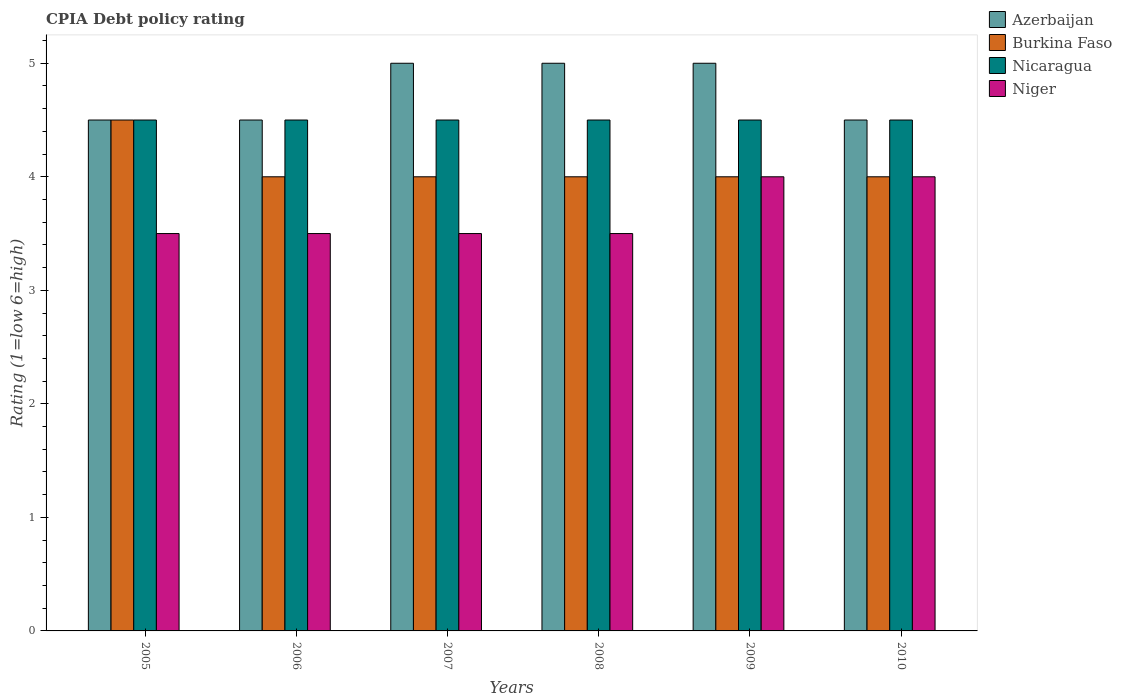How many different coloured bars are there?
Your answer should be very brief. 4. Are the number of bars per tick equal to the number of legend labels?
Your answer should be very brief. Yes. Are the number of bars on each tick of the X-axis equal?
Make the answer very short. Yes. How many bars are there on the 6th tick from the right?
Your answer should be very brief. 4. What is the label of the 6th group of bars from the left?
Your response must be concise. 2010. Across all years, what is the maximum CPIA rating in Niger?
Your answer should be very brief. 4. In which year was the CPIA rating in Niger minimum?
Make the answer very short. 2005. What is the total CPIA rating in Niger in the graph?
Offer a terse response. 22. What is the difference between the CPIA rating in Nicaragua in 2005 and that in 2009?
Offer a terse response. 0. What is the average CPIA rating in Azerbaijan per year?
Offer a terse response. 4.75. In the year 2005, what is the difference between the CPIA rating in Niger and CPIA rating in Azerbaijan?
Provide a succinct answer. -1. In how many years, is the CPIA rating in Azerbaijan greater than 3.4?
Your answer should be compact. 6. Is the CPIA rating in Niger in 2007 less than that in 2010?
Provide a succinct answer. Yes. Is the difference between the CPIA rating in Niger in 2006 and 2009 greater than the difference between the CPIA rating in Azerbaijan in 2006 and 2009?
Give a very brief answer. No. What does the 3rd bar from the left in 2008 represents?
Ensure brevity in your answer.  Nicaragua. What does the 1st bar from the right in 2006 represents?
Make the answer very short. Niger. Is it the case that in every year, the sum of the CPIA rating in Azerbaijan and CPIA rating in Niger is greater than the CPIA rating in Burkina Faso?
Your answer should be compact. Yes. Are the values on the major ticks of Y-axis written in scientific E-notation?
Your answer should be compact. No. Does the graph contain any zero values?
Your answer should be very brief. No. Where does the legend appear in the graph?
Your answer should be very brief. Top right. How many legend labels are there?
Ensure brevity in your answer.  4. What is the title of the graph?
Provide a succinct answer. CPIA Debt policy rating. Does "Sudan" appear as one of the legend labels in the graph?
Your answer should be very brief. No. What is the Rating (1=low 6=high) of Azerbaijan in 2005?
Provide a succinct answer. 4.5. What is the Rating (1=low 6=high) in Burkina Faso in 2005?
Your answer should be compact. 4.5. What is the Rating (1=low 6=high) in Nicaragua in 2005?
Your response must be concise. 4.5. What is the Rating (1=low 6=high) in Nicaragua in 2006?
Make the answer very short. 4.5. What is the Rating (1=low 6=high) in Niger in 2006?
Provide a succinct answer. 3.5. What is the Rating (1=low 6=high) in Burkina Faso in 2007?
Your answer should be compact. 4. What is the Rating (1=low 6=high) of Nicaragua in 2007?
Your answer should be compact. 4.5. What is the Rating (1=low 6=high) of Niger in 2007?
Your response must be concise. 3.5. What is the Rating (1=low 6=high) of Azerbaijan in 2008?
Your answer should be very brief. 5. What is the Rating (1=low 6=high) in Nicaragua in 2008?
Offer a terse response. 4.5. What is the Rating (1=low 6=high) in Azerbaijan in 2009?
Provide a short and direct response. 5. What is the Rating (1=low 6=high) in Nicaragua in 2009?
Offer a terse response. 4.5. What is the Rating (1=low 6=high) in Niger in 2009?
Your response must be concise. 4. What is the Rating (1=low 6=high) of Burkina Faso in 2010?
Provide a succinct answer. 4. What is the Rating (1=low 6=high) of Niger in 2010?
Your answer should be very brief. 4. Across all years, what is the maximum Rating (1=low 6=high) in Burkina Faso?
Offer a very short reply. 4.5. Across all years, what is the maximum Rating (1=low 6=high) of Niger?
Offer a terse response. 4. Across all years, what is the minimum Rating (1=low 6=high) in Burkina Faso?
Provide a short and direct response. 4. What is the total Rating (1=low 6=high) in Burkina Faso in the graph?
Ensure brevity in your answer.  24.5. What is the total Rating (1=low 6=high) in Niger in the graph?
Your answer should be compact. 22. What is the difference between the Rating (1=low 6=high) in Azerbaijan in 2005 and that in 2006?
Your answer should be compact. 0. What is the difference between the Rating (1=low 6=high) of Nicaragua in 2005 and that in 2006?
Your response must be concise. 0. What is the difference between the Rating (1=low 6=high) of Niger in 2005 and that in 2006?
Ensure brevity in your answer.  0. What is the difference between the Rating (1=low 6=high) in Burkina Faso in 2005 and that in 2007?
Keep it short and to the point. 0.5. What is the difference between the Rating (1=low 6=high) of Nicaragua in 2005 and that in 2007?
Ensure brevity in your answer.  0. What is the difference between the Rating (1=low 6=high) of Azerbaijan in 2005 and that in 2008?
Make the answer very short. -0.5. What is the difference between the Rating (1=low 6=high) in Nicaragua in 2005 and that in 2008?
Make the answer very short. 0. What is the difference between the Rating (1=low 6=high) of Azerbaijan in 2005 and that in 2009?
Keep it short and to the point. -0.5. What is the difference between the Rating (1=low 6=high) of Niger in 2005 and that in 2009?
Provide a succinct answer. -0.5. What is the difference between the Rating (1=low 6=high) of Nicaragua in 2005 and that in 2010?
Your response must be concise. 0. What is the difference between the Rating (1=low 6=high) in Niger in 2005 and that in 2010?
Your response must be concise. -0.5. What is the difference between the Rating (1=low 6=high) of Azerbaijan in 2006 and that in 2007?
Offer a terse response. -0.5. What is the difference between the Rating (1=low 6=high) in Burkina Faso in 2006 and that in 2007?
Ensure brevity in your answer.  0. What is the difference between the Rating (1=low 6=high) of Nicaragua in 2006 and that in 2007?
Provide a succinct answer. 0. What is the difference between the Rating (1=low 6=high) in Niger in 2006 and that in 2007?
Provide a succinct answer. 0. What is the difference between the Rating (1=low 6=high) in Azerbaijan in 2006 and that in 2009?
Provide a succinct answer. -0.5. What is the difference between the Rating (1=low 6=high) of Niger in 2006 and that in 2009?
Keep it short and to the point. -0.5. What is the difference between the Rating (1=low 6=high) of Azerbaijan in 2006 and that in 2010?
Provide a succinct answer. 0. What is the difference between the Rating (1=low 6=high) in Burkina Faso in 2006 and that in 2010?
Your answer should be very brief. 0. What is the difference between the Rating (1=low 6=high) of Niger in 2006 and that in 2010?
Give a very brief answer. -0.5. What is the difference between the Rating (1=low 6=high) in Azerbaijan in 2007 and that in 2008?
Provide a short and direct response. 0. What is the difference between the Rating (1=low 6=high) of Burkina Faso in 2007 and that in 2008?
Your answer should be very brief. 0. What is the difference between the Rating (1=low 6=high) of Azerbaijan in 2007 and that in 2009?
Keep it short and to the point. 0. What is the difference between the Rating (1=low 6=high) of Nicaragua in 2007 and that in 2009?
Keep it short and to the point. 0. What is the difference between the Rating (1=low 6=high) of Azerbaijan in 2007 and that in 2010?
Provide a short and direct response. 0.5. What is the difference between the Rating (1=low 6=high) of Burkina Faso in 2008 and that in 2010?
Offer a very short reply. 0. What is the difference between the Rating (1=low 6=high) in Burkina Faso in 2009 and that in 2010?
Your answer should be compact. 0. What is the difference between the Rating (1=low 6=high) in Azerbaijan in 2005 and the Rating (1=low 6=high) in Nicaragua in 2006?
Your answer should be very brief. 0. What is the difference between the Rating (1=low 6=high) of Nicaragua in 2005 and the Rating (1=low 6=high) of Niger in 2006?
Your response must be concise. 1. What is the difference between the Rating (1=low 6=high) in Azerbaijan in 2005 and the Rating (1=low 6=high) in Burkina Faso in 2007?
Your answer should be very brief. 0.5. What is the difference between the Rating (1=low 6=high) in Azerbaijan in 2005 and the Rating (1=low 6=high) in Nicaragua in 2007?
Offer a very short reply. 0. What is the difference between the Rating (1=low 6=high) in Azerbaijan in 2005 and the Rating (1=low 6=high) in Niger in 2007?
Your response must be concise. 1. What is the difference between the Rating (1=low 6=high) of Burkina Faso in 2005 and the Rating (1=low 6=high) of Nicaragua in 2007?
Offer a terse response. 0. What is the difference between the Rating (1=low 6=high) of Azerbaijan in 2005 and the Rating (1=low 6=high) of Burkina Faso in 2008?
Your answer should be very brief. 0.5. What is the difference between the Rating (1=low 6=high) in Azerbaijan in 2005 and the Rating (1=low 6=high) in Nicaragua in 2008?
Make the answer very short. 0. What is the difference between the Rating (1=low 6=high) of Azerbaijan in 2005 and the Rating (1=low 6=high) of Niger in 2008?
Ensure brevity in your answer.  1. What is the difference between the Rating (1=low 6=high) of Burkina Faso in 2005 and the Rating (1=low 6=high) of Nicaragua in 2008?
Provide a succinct answer. 0. What is the difference between the Rating (1=low 6=high) of Azerbaijan in 2005 and the Rating (1=low 6=high) of Burkina Faso in 2009?
Keep it short and to the point. 0.5. What is the difference between the Rating (1=low 6=high) of Azerbaijan in 2005 and the Rating (1=low 6=high) of Nicaragua in 2009?
Ensure brevity in your answer.  0. What is the difference between the Rating (1=low 6=high) in Azerbaijan in 2005 and the Rating (1=low 6=high) in Niger in 2009?
Offer a terse response. 0.5. What is the difference between the Rating (1=low 6=high) of Burkina Faso in 2005 and the Rating (1=low 6=high) of Niger in 2009?
Give a very brief answer. 0.5. What is the difference between the Rating (1=low 6=high) in Nicaragua in 2005 and the Rating (1=low 6=high) in Niger in 2009?
Offer a very short reply. 0.5. What is the difference between the Rating (1=low 6=high) of Azerbaijan in 2006 and the Rating (1=low 6=high) of Nicaragua in 2007?
Offer a very short reply. 0. What is the difference between the Rating (1=low 6=high) of Burkina Faso in 2006 and the Rating (1=low 6=high) of Niger in 2007?
Offer a terse response. 0.5. What is the difference between the Rating (1=low 6=high) in Nicaragua in 2006 and the Rating (1=low 6=high) in Niger in 2007?
Your answer should be compact. 1. What is the difference between the Rating (1=low 6=high) in Azerbaijan in 2006 and the Rating (1=low 6=high) in Nicaragua in 2008?
Keep it short and to the point. 0. What is the difference between the Rating (1=low 6=high) of Azerbaijan in 2006 and the Rating (1=low 6=high) of Niger in 2008?
Provide a succinct answer. 1. What is the difference between the Rating (1=low 6=high) in Burkina Faso in 2006 and the Rating (1=low 6=high) in Niger in 2008?
Your answer should be very brief. 0.5. What is the difference between the Rating (1=low 6=high) in Burkina Faso in 2006 and the Rating (1=low 6=high) in Nicaragua in 2009?
Keep it short and to the point. -0.5. What is the difference between the Rating (1=low 6=high) of Burkina Faso in 2006 and the Rating (1=low 6=high) of Niger in 2009?
Provide a short and direct response. 0. What is the difference between the Rating (1=low 6=high) in Nicaragua in 2006 and the Rating (1=low 6=high) in Niger in 2009?
Offer a terse response. 0.5. What is the difference between the Rating (1=low 6=high) in Azerbaijan in 2006 and the Rating (1=low 6=high) in Burkina Faso in 2010?
Offer a terse response. 0.5. What is the difference between the Rating (1=low 6=high) of Azerbaijan in 2006 and the Rating (1=low 6=high) of Nicaragua in 2010?
Your answer should be compact. 0. What is the difference between the Rating (1=low 6=high) in Azerbaijan in 2006 and the Rating (1=low 6=high) in Niger in 2010?
Keep it short and to the point. 0.5. What is the difference between the Rating (1=low 6=high) in Nicaragua in 2006 and the Rating (1=low 6=high) in Niger in 2010?
Keep it short and to the point. 0.5. What is the difference between the Rating (1=low 6=high) of Azerbaijan in 2007 and the Rating (1=low 6=high) of Burkina Faso in 2008?
Your answer should be compact. 1. What is the difference between the Rating (1=low 6=high) in Burkina Faso in 2007 and the Rating (1=low 6=high) in Niger in 2008?
Make the answer very short. 0.5. What is the difference between the Rating (1=low 6=high) of Azerbaijan in 2007 and the Rating (1=low 6=high) of Burkina Faso in 2009?
Offer a very short reply. 1. What is the difference between the Rating (1=low 6=high) of Burkina Faso in 2007 and the Rating (1=low 6=high) of Niger in 2010?
Offer a terse response. 0. What is the difference between the Rating (1=low 6=high) in Azerbaijan in 2008 and the Rating (1=low 6=high) in Burkina Faso in 2009?
Your answer should be very brief. 1. What is the difference between the Rating (1=low 6=high) in Azerbaijan in 2008 and the Rating (1=low 6=high) in Niger in 2009?
Your response must be concise. 1. What is the difference between the Rating (1=low 6=high) of Burkina Faso in 2008 and the Rating (1=low 6=high) of Niger in 2009?
Ensure brevity in your answer.  0. What is the difference between the Rating (1=low 6=high) in Nicaragua in 2008 and the Rating (1=low 6=high) in Niger in 2009?
Give a very brief answer. 0.5. What is the difference between the Rating (1=low 6=high) of Azerbaijan in 2008 and the Rating (1=low 6=high) of Niger in 2010?
Provide a succinct answer. 1. What is the difference between the Rating (1=low 6=high) of Burkina Faso in 2008 and the Rating (1=low 6=high) of Nicaragua in 2010?
Your response must be concise. -0.5. What is the difference between the Rating (1=low 6=high) in Burkina Faso in 2009 and the Rating (1=low 6=high) in Nicaragua in 2010?
Give a very brief answer. -0.5. What is the difference between the Rating (1=low 6=high) in Burkina Faso in 2009 and the Rating (1=low 6=high) in Niger in 2010?
Your answer should be compact. 0. What is the average Rating (1=low 6=high) of Azerbaijan per year?
Your answer should be compact. 4.75. What is the average Rating (1=low 6=high) of Burkina Faso per year?
Offer a terse response. 4.08. What is the average Rating (1=low 6=high) in Niger per year?
Provide a short and direct response. 3.67. In the year 2005, what is the difference between the Rating (1=low 6=high) in Azerbaijan and Rating (1=low 6=high) in Burkina Faso?
Your response must be concise. 0. In the year 2005, what is the difference between the Rating (1=low 6=high) of Azerbaijan and Rating (1=low 6=high) of Nicaragua?
Make the answer very short. 0. In the year 2005, what is the difference between the Rating (1=low 6=high) of Azerbaijan and Rating (1=low 6=high) of Niger?
Your response must be concise. 1. In the year 2005, what is the difference between the Rating (1=low 6=high) in Burkina Faso and Rating (1=low 6=high) in Nicaragua?
Provide a succinct answer. 0. In the year 2005, what is the difference between the Rating (1=low 6=high) in Nicaragua and Rating (1=low 6=high) in Niger?
Provide a succinct answer. 1. In the year 2006, what is the difference between the Rating (1=low 6=high) of Azerbaijan and Rating (1=low 6=high) of Nicaragua?
Your answer should be very brief. 0. In the year 2006, what is the difference between the Rating (1=low 6=high) of Nicaragua and Rating (1=low 6=high) of Niger?
Your answer should be very brief. 1. In the year 2007, what is the difference between the Rating (1=low 6=high) of Azerbaijan and Rating (1=low 6=high) of Burkina Faso?
Your answer should be very brief. 1. In the year 2007, what is the difference between the Rating (1=low 6=high) of Burkina Faso and Rating (1=low 6=high) of Nicaragua?
Offer a terse response. -0.5. In the year 2007, what is the difference between the Rating (1=low 6=high) in Burkina Faso and Rating (1=low 6=high) in Niger?
Offer a terse response. 0.5. In the year 2008, what is the difference between the Rating (1=low 6=high) in Azerbaijan and Rating (1=low 6=high) in Burkina Faso?
Offer a terse response. 1. In the year 2008, what is the difference between the Rating (1=low 6=high) of Azerbaijan and Rating (1=low 6=high) of Nicaragua?
Your response must be concise. 0.5. In the year 2009, what is the difference between the Rating (1=low 6=high) in Azerbaijan and Rating (1=low 6=high) in Nicaragua?
Your response must be concise. 0.5. In the year 2010, what is the difference between the Rating (1=low 6=high) of Azerbaijan and Rating (1=low 6=high) of Burkina Faso?
Provide a short and direct response. 0.5. In the year 2010, what is the difference between the Rating (1=low 6=high) in Azerbaijan and Rating (1=low 6=high) in Nicaragua?
Keep it short and to the point. 0. In the year 2010, what is the difference between the Rating (1=low 6=high) in Azerbaijan and Rating (1=low 6=high) in Niger?
Offer a very short reply. 0.5. In the year 2010, what is the difference between the Rating (1=low 6=high) of Nicaragua and Rating (1=low 6=high) of Niger?
Provide a succinct answer. 0.5. What is the ratio of the Rating (1=low 6=high) in Nicaragua in 2005 to that in 2006?
Your response must be concise. 1. What is the ratio of the Rating (1=low 6=high) of Azerbaijan in 2005 to that in 2007?
Keep it short and to the point. 0.9. What is the ratio of the Rating (1=low 6=high) in Nicaragua in 2005 to that in 2007?
Provide a short and direct response. 1. What is the ratio of the Rating (1=low 6=high) in Niger in 2005 to that in 2007?
Give a very brief answer. 1. What is the ratio of the Rating (1=low 6=high) in Azerbaijan in 2005 to that in 2008?
Make the answer very short. 0.9. What is the ratio of the Rating (1=low 6=high) of Burkina Faso in 2005 to that in 2008?
Offer a terse response. 1.12. What is the ratio of the Rating (1=low 6=high) of Niger in 2005 to that in 2008?
Keep it short and to the point. 1. What is the ratio of the Rating (1=low 6=high) of Azerbaijan in 2005 to that in 2009?
Your response must be concise. 0.9. What is the ratio of the Rating (1=low 6=high) of Burkina Faso in 2005 to that in 2009?
Provide a succinct answer. 1.12. What is the ratio of the Rating (1=low 6=high) of Nicaragua in 2005 to that in 2009?
Offer a very short reply. 1. What is the ratio of the Rating (1=low 6=high) in Niger in 2005 to that in 2009?
Your response must be concise. 0.88. What is the ratio of the Rating (1=low 6=high) in Azerbaijan in 2005 to that in 2010?
Offer a terse response. 1. What is the ratio of the Rating (1=low 6=high) in Burkina Faso in 2005 to that in 2010?
Make the answer very short. 1.12. What is the ratio of the Rating (1=low 6=high) of Nicaragua in 2005 to that in 2010?
Ensure brevity in your answer.  1. What is the ratio of the Rating (1=low 6=high) of Burkina Faso in 2006 to that in 2007?
Your response must be concise. 1. What is the ratio of the Rating (1=low 6=high) in Burkina Faso in 2006 to that in 2008?
Make the answer very short. 1. What is the ratio of the Rating (1=low 6=high) of Nicaragua in 2006 to that in 2008?
Keep it short and to the point. 1. What is the ratio of the Rating (1=low 6=high) in Niger in 2006 to that in 2008?
Keep it short and to the point. 1. What is the ratio of the Rating (1=low 6=high) in Burkina Faso in 2006 to that in 2009?
Your answer should be very brief. 1. What is the ratio of the Rating (1=low 6=high) of Nicaragua in 2006 to that in 2009?
Offer a very short reply. 1. What is the ratio of the Rating (1=low 6=high) of Burkina Faso in 2006 to that in 2010?
Ensure brevity in your answer.  1. What is the ratio of the Rating (1=low 6=high) in Nicaragua in 2006 to that in 2010?
Offer a terse response. 1. What is the ratio of the Rating (1=low 6=high) in Niger in 2006 to that in 2010?
Keep it short and to the point. 0.88. What is the ratio of the Rating (1=low 6=high) of Burkina Faso in 2007 to that in 2008?
Offer a terse response. 1. What is the ratio of the Rating (1=low 6=high) of Azerbaijan in 2007 to that in 2009?
Offer a very short reply. 1. What is the ratio of the Rating (1=low 6=high) in Burkina Faso in 2007 to that in 2010?
Offer a very short reply. 1. What is the ratio of the Rating (1=low 6=high) of Azerbaijan in 2008 to that in 2009?
Your answer should be compact. 1. What is the ratio of the Rating (1=low 6=high) of Nicaragua in 2008 to that in 2009?
Ensure brevity in your answer.  1. What is the ratio of the Rating (1=low 6=high) in Burkina Faso in 2009 to that in 2010?
Your answer should be very brief. 1. What is the ratio of the Rating (1=low 6=high) of Nicaragua in 2009 to that in 2010?
Ensure brevity in your answer.  1. What is the ratio of the Rating (1=low 6=high) in Niger in 2009 to that in 2010?
Ensure brevity in your answer.  1. What is the difference between the highest and the second highest Rating (1=low 6=high) of Niger?
Your answer should be very brief. 0. What is the difference between the highest and the lowest Rating (1=low 6=high) in Burkina Faso?
Your response must be concise. 0.5. What is the difference between the highest and the lowest Rating (1=low 6=high) in Niger?
Ensure brevity in your answer.  0.5. 